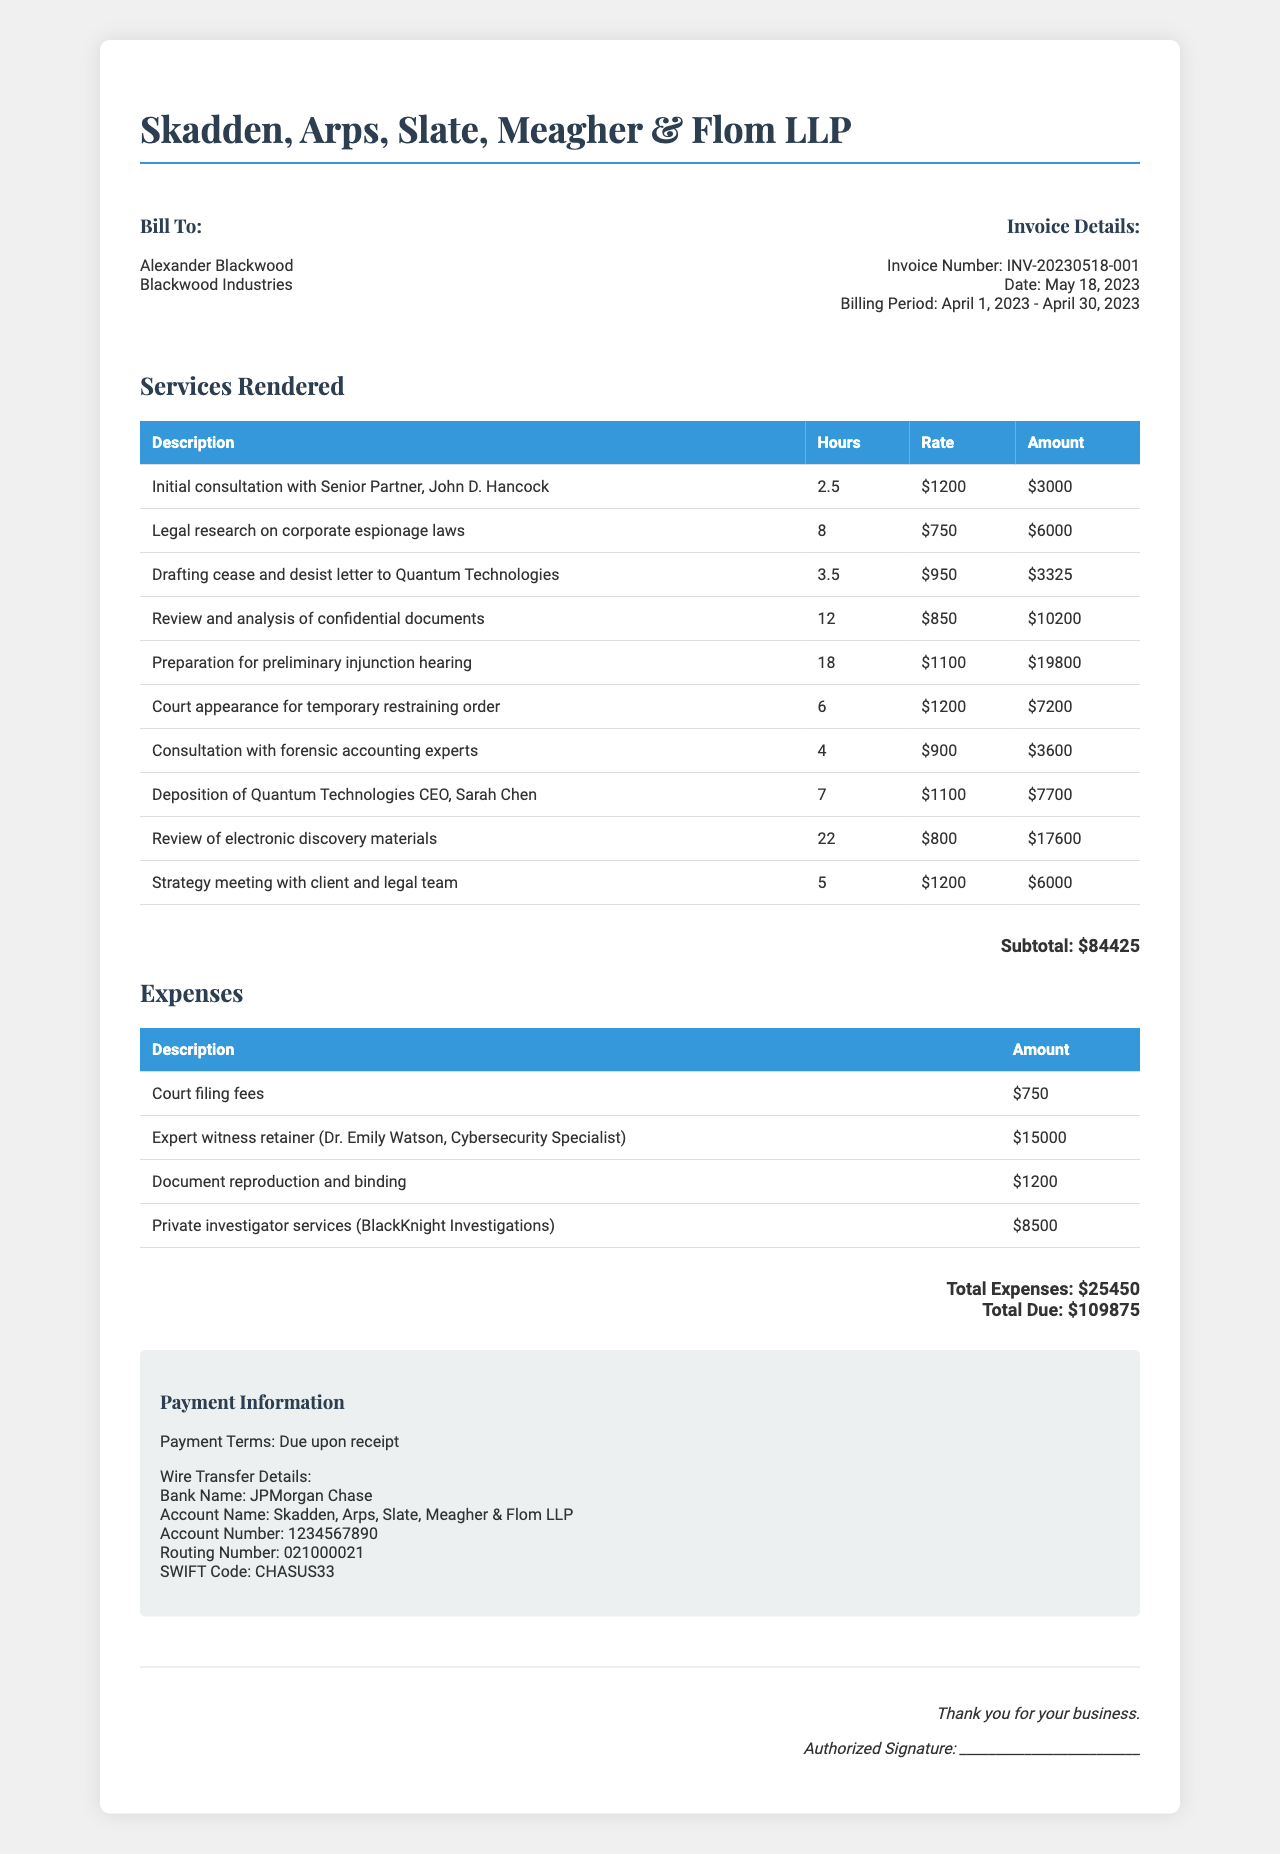what is the name of the law firm? The name of the law firm is listed at the top of the document.
Answer: Skadden, Arps, Slate, Meagher & Flom LLP what is the invoice number? The invoice number can be found in the invoice details section.
Answer: INV-20230518-001 how much did the court appearance for temporary restraining order cost? The cost for the court appearance is itemized in the services rendered table.
Answer: $7200 what were the total expenses? Total expenses are summed up in a dedicated section of the document.
Answer: $25450 who is the client? The client's name is mentioned in the bill to section of the document.
Answer: Alexander Blackwood how many hours were spent on legal research on corporate espionage laws? The hours spent are detailed alongside the service description in the items list.
Answer: 8 what is the total amount due? The total due amount is highlighted at the end of the invoice.
Answer: $109875 what is the payment term? Payment terms are stated in the payment information section.
Answer: Due upon receipt how much was spent on the expert witness retainer? The amount spent on the expert witness is listed in the expenses table.
Answer: $15000 what is the bank name for wire transfer? The bank name is found in the wire transfer details section.
Answer: JPMorgan Chase 